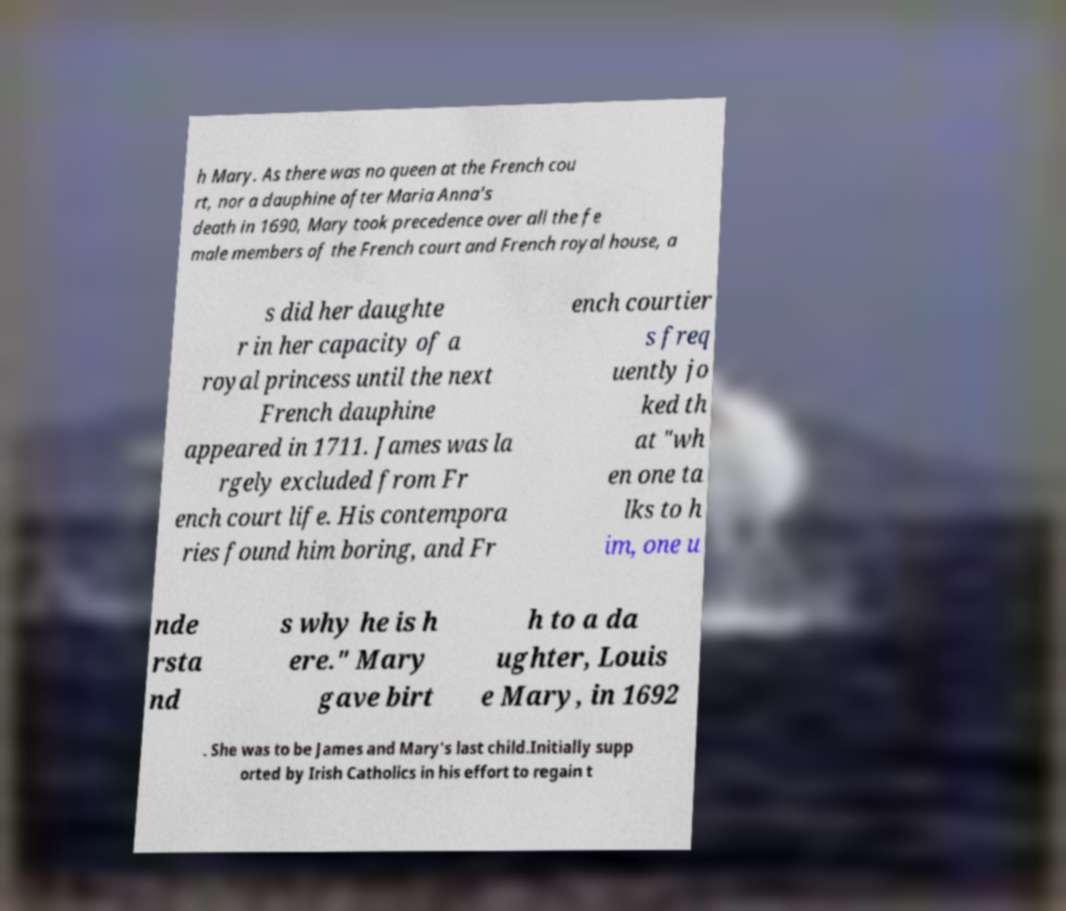Can you accurately transcribe the text from the provided image for me? h Mary. As there was no queen at the French cou rt, nor a dauphine after Maria Anna's death in 1690, Mary took precedence over all the fe male members of the French court and French royal house, a s did her daughte r in her capacity of a royal princess until the next French dauphine appeared in 1711. James was la rgely excluded from Fr ench court life. His contempora ries found him boring, and Fr ench courtier s freq uently jo ked th at "wh en one ta lks to h im, one u nde rsta nd s why he is h ere." Mary gave birt h to a da ughter, Louis e Mary, in 1692 . She was to be James and Mary's last child.Initially supp orted by Irish Catholics in his effort to regain t 